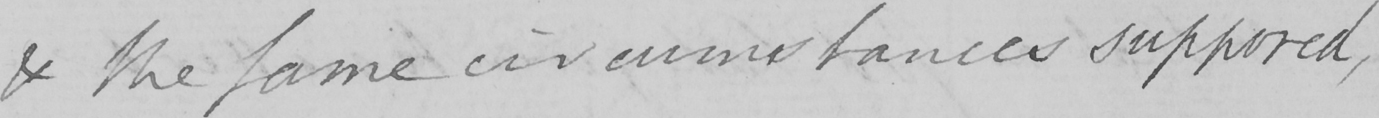Transcribe the text shown in this historical manuscript line. & the same circumstances supposed , 